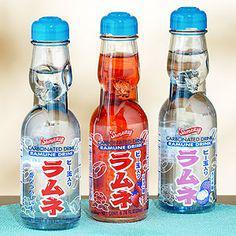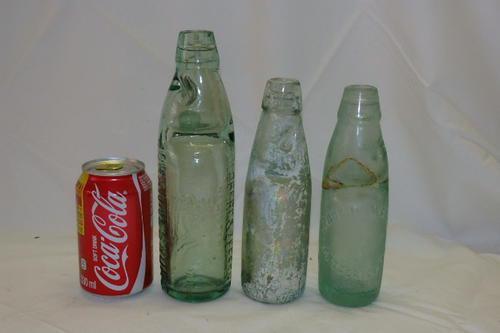The first image is the image on the left, the second image is the image on the right. For the images shown, is this caption "One of the bottles is filled with red liquid." true? Answer yes or no. Yes. 